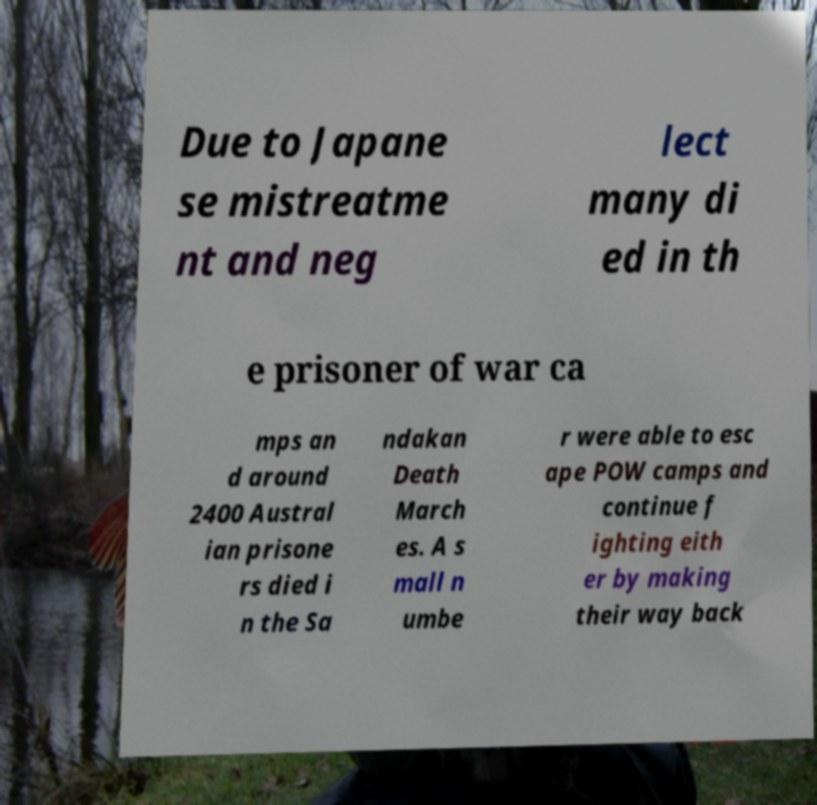Please read and relay the text visible in this image. What does it say? Due to Japane se mistreatme nt and neg lect many di ed in th e prisoner of war ca mps an d around 2400 Austral ian prisone rs died i n the Sa ndakan Death March es. A s mall n umbe r were able to esc ape POW camps and continue f ighting eith er by making their way back 